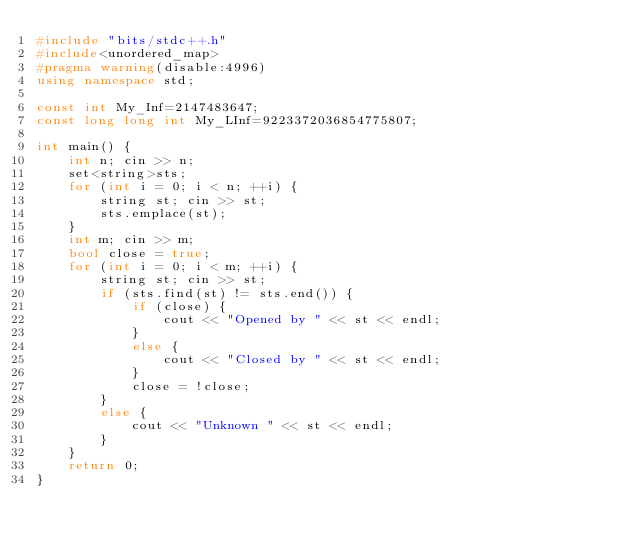Convert code to text. <code><loc_0><loc_0><loc_500><loc_500><_C++_>#include "bits/stdc++.h"
#include<unordered_map>
#pragma warning(disable:4996)
using namespace std;

const int My_Inf=2147483647;
const long long int My_LInf=9223372036854775807;

int main() {
	int n; cin >> n;
	set<string>sts;
	for (int i = 0; i < n; ++i) {
		string st; cin >> st;
		sts.emplace(st);
	}
	int m; cin >> m;
	bool close = true;
	for (int i = 0; i < m; ++i) {
		string st; cin >> st;
		if (sts.find(st) != sts.end()) {
			if (close) {
				cout << "Opened by " << st << endl;
			}
			else {
				cout << "Closed by " << st << endl;
			}
			close = !close;
		}
		else {
			cout << "Unknown " << st << endl;
		}
	}
	return 0;
}</code> 